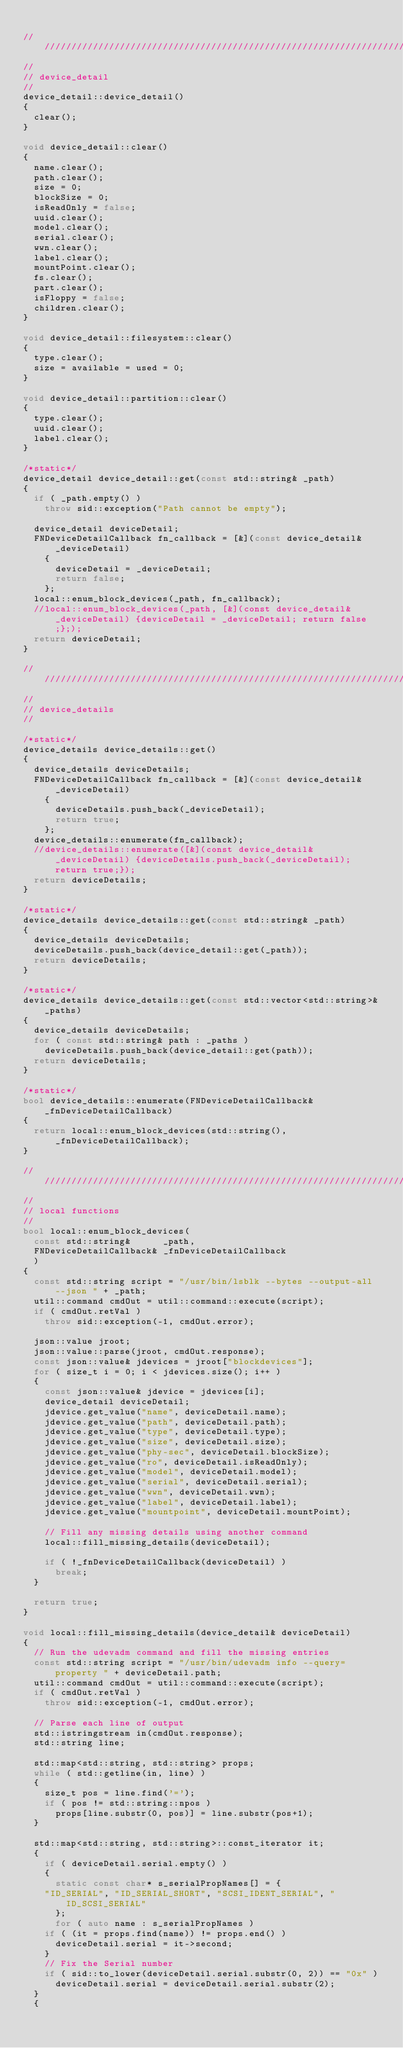Convert code to text. <code><loc_0><loc_0><loc_500><loc_500><_C++_>
//////////////////////////////////////////////////////////////////////////////////////////////////////
//
// device_detail
//
device_detail::device_detail()
{
  clear();
}

void device_detail::clear()
{
  name.clear();
  path.clear();
  size = 0;
  blockSize = 0;
  isReadOnly = false;
  uuid.clear();
  model.clear();
  serial.clear();
  wwn.clear();
  label.clear();
  mountPoint.clear();
  fs.clear();
  part.clear();
  isFloppy = false;
  children.clear();
}

void device_detail::filesystem::clear()
{
  type.clear();
  size = available = used = 0;
}

void device_detail::partition::clear()
{
  type.clear();
  uuid.clear();
  label.clear();
}

/*static*/
device_detail device_detail::get(const std::string& _path)
{
  if ( _path.empty() )
    throw sid::exception("Path cannot be empty");

  device_detail deviceDetail;
  FNDeviceDetailCallback fn_callback = [&](const device_detail& _deviceDetail)
    {
      deviceDetail = _deviceDetail;
      return false;
    };
  local::enum_block_devices(_path, fn_callback);
  //local::enum_block_devices(_path, [&](const device_detail& _deviceDetail) {deviceDetail = _deviceDetail; return false;};);
  return deviceDetail;
}

//////////////////////////////////////////////////////////////////////////////////////////////////////
//
// device_details
//

/*static*/
device_details device_details::get()
{
  device_details deviceDetails;
  FNDeviceDetailCallback fn_callback = [&](const device_detail& _deviceDetail)
    {
      deviceDetails.push_back(_deviceDetail);
      return true;
    };
  device_details::enumerate(fn_callback);
  //device_details::enumerate([&](const device_detail& _deviceDetail) {deviceDetails.push_back(_deviceDetail); return true;});
  return deviceDetails;
}

/*static*/
device_details device_details::get(const std::string& _path)
{
  device_details deviceDetails;
  deviceDetails.push_back(device_detail::get(_path));
  return deviceDetails;
}

/*static*/
device_details device_details::get(const std::vector<std::string>& _paths)
{
  device_details deviceDetails;
  for ( const std::string& path : _paths )
    deviceDetails.push_back(device_detail::get(path));
  return deviceDetails;
}

/*static*/
bool device_details::enumerate(FNDeviceDetailCallback& _fnDeviceDetailCallback)
{
  return local::enum_block_devices(std::string(), _fnDeviceDetailCallback);
}

//////////////////////////////////////////////////////////////////////////////////////////////////////
//
// local functions
//
bool local::enum_block_devices(
  const std::string&      _path,
  FNDeviceDetailCallback& _fnDeviceDetailCallback
  )
{
  const std::string script = "/usr/bin/lsblk --bytes --output-all --json " + _path;
  util::command cmdOut = util::command::execute(script);
  if ( cmdOut.retVal )
    throw sid::exception(-1, cmdOut.error);

  json::value jroot;
  json::value::parse(jroot, cmdOut.response);
  const json::value& jdevices = jroot["blockdevices"];
  for ( size_t i = 0; i < jdevices.size(); i++ )
  {
    const json::value& jdevice = jdevices[i];
    device_detail deviceDetail;
    jdevice.get_value("name", deviceDetail.name);
    jdevice.get_value("path", deviceDetail.path);
    jdevice.get_value("type", deviceDetail.type);
    jdevice.get_value("size", deviceDetail.size);
    jdevice.get_value("phy-sec", deviceDetail.blockSize);
    jdevice.get_value("ro", deviceDetail.isReadOnly);
    jdevice.get_value("model", deviceDetail.model);
    jdevice.get_value("serial", deviceDetail.serial);
    jdevice.get_value("wwn", deviceDetail.wwn);
    jdevice.get_value("label", deviceDetail.label);
    jdevice.get_value("mountpoint", deviceDetail.mountPoint);

    // Fill any missing details using another command
    local::fill_missing_details(deviceDetail);

    if ( !_fnDeviceDetailCallback(deviceDetail) )
      break;
  }

  return true;
}

void local::fill_missing_details(device_detail& deviceDetail)
{
  // Run the udevadm command and fill the missing entries
  const std::string script = "/usr/bin/udevadm info --query=property " + deviceDetail.path;
  util::command cmdOut = util::command::execute(script);
  if ( cmdOut.retVal )
    throw sid::exception(-1, cmdOut.error);

  // Parse each line of output
  std::istringstream in(cmdOut.response);
  std::string line;

  std::map<std::string, std::string> props;
  while ( std::getline(in, line) )
  {
    size_t pos = line.find('=');
    if ( pos != std::string::npos )
      props[line.substr(0, pos)] = line.substr(pos+1);
  }

  std::map<std::string, std::string>::const_iterator it;
  {
    if ( deviceDetail.serial.empty() )
    {
      static const char* s_serialPropNames[] = {
	"ID_SERIAL", "ID_SERIAL_SHORT", "SCSI_IDENT_SERIAL", "ID_SCSI_SERIAL"
      };
      for ( auto name : s_serialPropNames )
	if ( (it = props.find(name)) != props.end() )
	  deviceDetail.serial = it->second;
    }
    // Fix the Serial number
    if ( sid::to_lower(deviceDetail.serial.substr(0, 2)) == "0x" )
      deviceDetail.serial = deviceDetail.serial.substr(2);
  }
  {</code> 